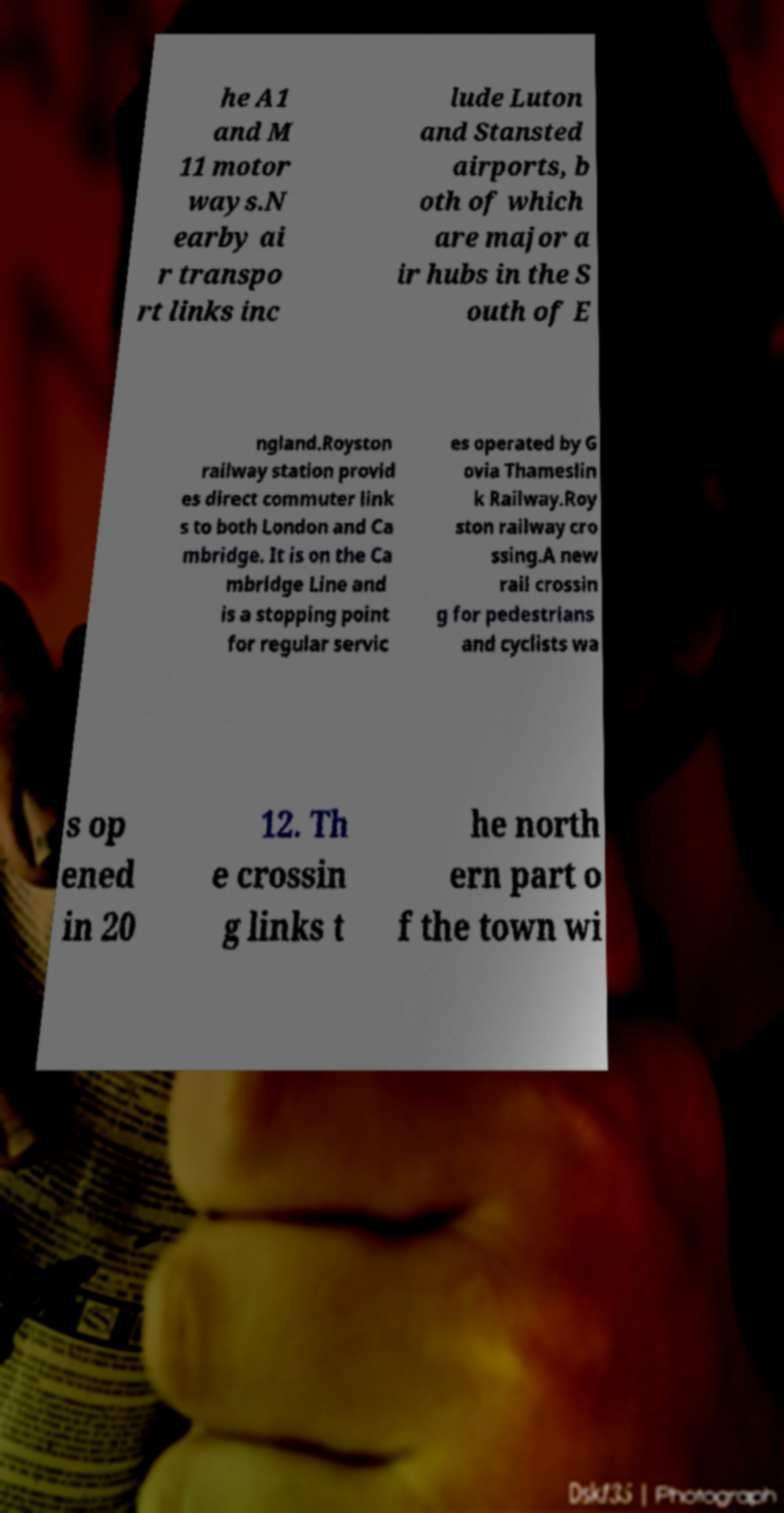What messages or text are displayed in this image? I need them in a readable, typed format. he A1 and M 11 motor ways.N earby ai r transpo rt links inc lude Luton and Stansted airports, b oth of which are major a ir hubs in the S outh of E ngland.Royston railway station provid es direct commuter link s to both London and Ca mbridge. It is on the Ca mbridge Line and is a stopping point for regular servic es operated by G ovia Thameslin k Railway.Roy ston railway cro ssing.A new rail crossin g for pedestrians and cyclists wa s op ened in 20 12. Th e crossin g links t he north ern part o f the town wi 